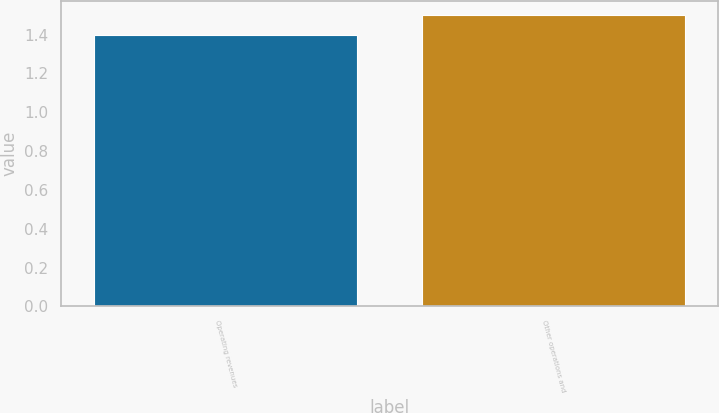<chart> <loc_0><loc_0><loc_500><loc_500><bar_chart><fcel>Operating revenues<fcel>Other operations and<nl><fcel>1.4<fcel>1.5<nl></chart> 